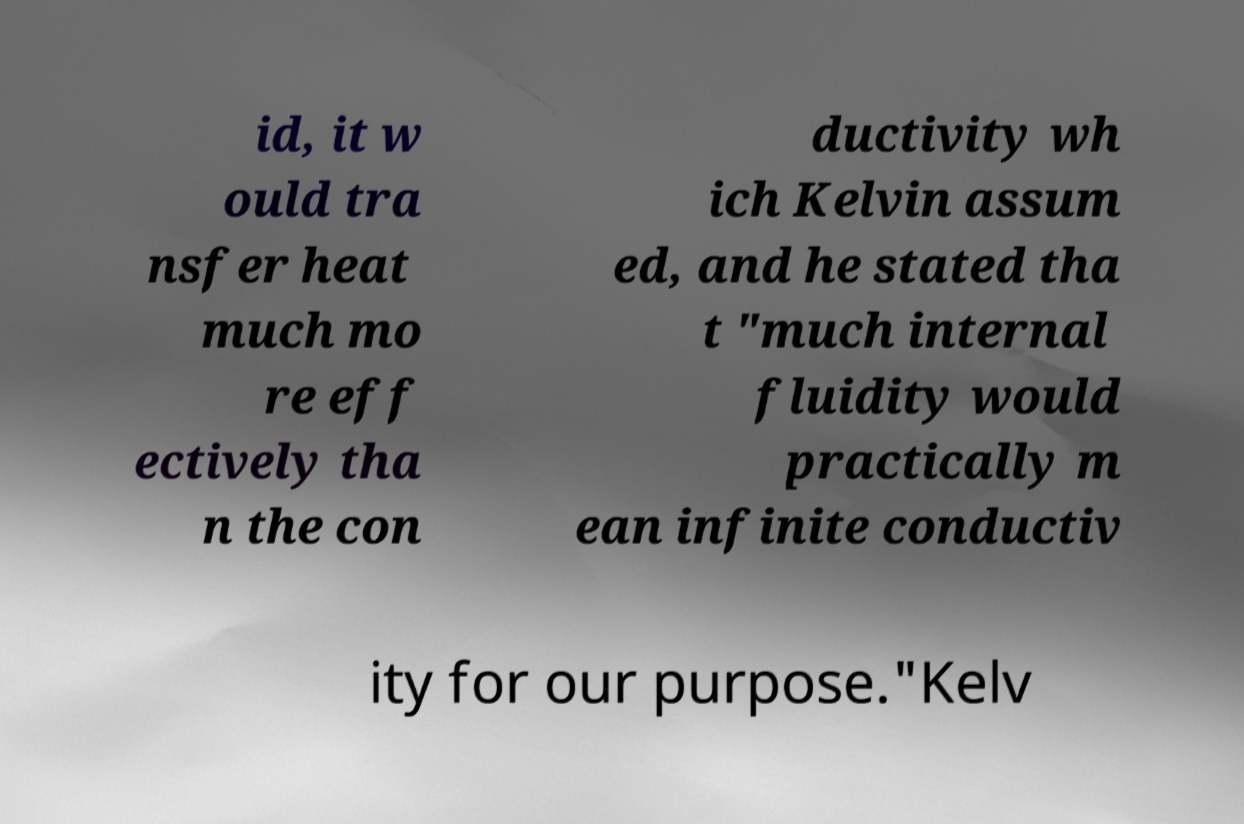What messages or text are displayed in this image? I need them in a readable, typed format. id, it w ould tra nsfer heat much mo re eff ectively tha n the con ductivity wh ich Kelvin assum ed, and he stated tha t "much internal fluidity would practically m ean infinite conductiv ity for our purpose."Kelv 